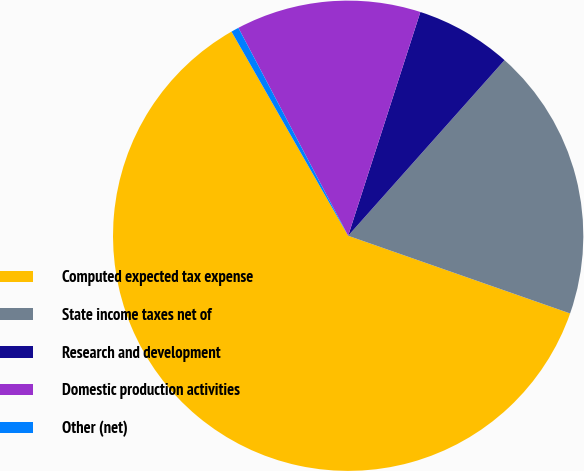<chart> <loc_0><loc_0><loc_500><loc_500><pie_chart><fcel>Computed expected tax expense<fcel>State income taxes net of<fcel>Research and development<fcel>Domestic production activities<fcel>Other (net)<nl><fcel>61.38%<fcel>18.78%<fcel>6.61%<fcel>12.7%<fcel>0.53%<nl></chart> 